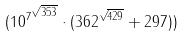<formula> <loc_0><loc_0><loc_500><loc_500>( { 1 0 ^ { 7 } } ^ { \sqrt { 3 5 3 } } \cdot ( 3 6 2 ^ { \sqrt { 4 2 9 } } + 2 9 7 ) )</formula> 